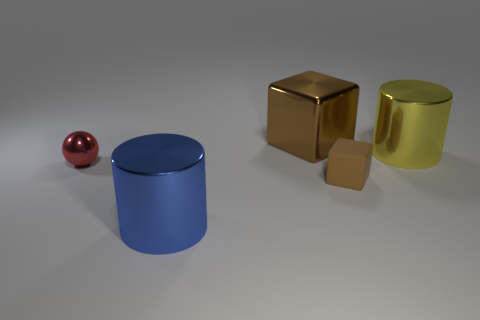The cylinder that is to the right of the blue shiny cylinder is what color?
Provide a succinct answer. Yellow. There is a brown rubber block; is its size the same as the cylinder that is on the left side of the big block?
Your answer should be compact. No. What is the size of the metal thing that is both to the left of the large brown cube and right of the red shiny thing?
Make the answer very short. Large. Is there another object that has the same material as the yellow thing?
Make the answer very short. Yes. The big blue shiny object is what shape?
Provide a succinct answer. Cylinder. Do the yellow thing and the rubber cube have the same size?
Your answer should be very brief. No. What number of other things are there of the same shape as the small red thing?
Your answer should be compact. 0. The brown object that is on the right side of the large brown shiny cube has what shape?
Give a very brief answer. Cube. There is a brown thing that is behind the red thing; is it the same shape as the metallic thing that is in front of the ball?
Your answer should be compact. No. Is the number of tiny matte objects that are right of the small brown rubber thing the same as the number of big blue cubes?
Offer a terse response. Yes. 